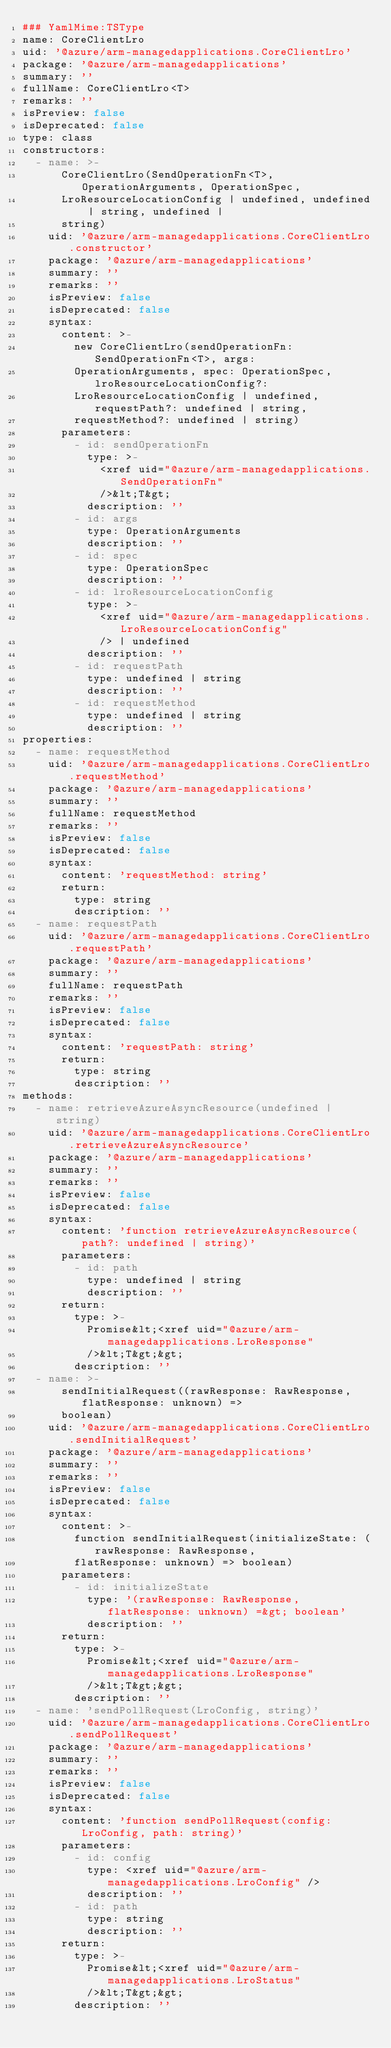<code> <loc_0><loc_0><loc_500><loc_500><_YAML_>### YamlMime:TSType
name: CoreClientLro
uid: '@azure/arm-managedapplications.CoreClientLro'
package: '@azure/arm-managedapplications'
summary: ''
fullName: CoreClientLro<T>
remarks: ''
isPreview: false
isDeprecated: false
type: class
constructors:
  - name: >-
      CoreClientLro(SendOperationFn<T>, OperationArguments, OperationSpec,
      LroResourceLocationConfig | undefined, undefined | string, undefined |
      string)
    uid: '@azure/arm-managedapplications.CoreClientLro.constructor'
    package: '@azure/arm-managedapplications'
    summary: ''
    remarks: ''
    isPreview: false
    isDeprecated: false
    syntax:
      content: >-
        new CoreClientLro(sendOperationFn: SendOperationFn<T>, args:
        OperationArguments, spec: OperationSpec, lroResourceLocationConfig?:
        LroResourceLocationConfig | undefined, requestPath?: undefined | string,
        requestMethod?: undefined | string)
      parameters:
        - id: sendOperationFn
          type: >-
            <xref uid="@azure/arm-managedapplications.SendOperationFn"
            />&lt;T&gt;
          description: ''
        - id: args
          type: OperationArguments
          description: ''
        - id: spec
          type: OperationSpec
          description: ''
        - id: lroResourceLocationConfig
          type: >-
            <xref uid="@azure/arm-managedapplications.LroResourceLocationConfig"
            /> | undefined
          description: ''
        - id: requestPath
          type: undefined | string
          description: ''
        - id: requestMethod
          type: undefined | string
          description: ''
properties:
  - name: requestMethod
    uid: '@azure/arm-managedapplications.CoreClientLro.requestMethod'
    package: '@azure/arm-managedapplications'
    summary: ''
    fullName: requestMethod
    remarks: ''
    isPreview: false
    isDeprecated: false
    syntax:
      content: 'requestMethod: string'
      return:
        type: string
        description: ''
  - name: requestPath
    uid: '@azure/arm-managedapplications.CoreClientLro.requestPath'
    package: '@azure/arm-managedapplications'
    summary: ''
    fullName: requestPath
    remarks: ''
    isPreview: false
    isDeprecated: false
    syntax:
      content: 'requestPath: string'
      return:
        type: string
        description: ''
methods:
  - name: retrieveAzureAsyncResource(undefined | string)
    uid: '@azure/arm-managedapplications.CoreClientLro.retrieveAzureAsyncResource'
    package: '@azure/arm-managedapplications'
    summary: ''
    remarks: ''
    isPreview: false
    isDeprecated: false
    syntax:
      content: 'function retrieveAzureAsyncResource(path?: undefined | string)'
      parameters:
        - id: path
          type: undefined | string
          description: ''
      return:
        type: >-
          Promise&lt;<xref uid="@azure/arm-managedapplications.LroResponse"
          />&lt;T&gt;&gt;
        description: ''
  - name: >-
      sendInitialRequest((rawResponse: RawResponse, flatResponse: unknown) =>
      boolean)
    uid: '@azure/arm-managedapplications.CoreClientLro.sendInitialRequest'
    package: '@azure/arm-managedapplications'
    summary: ''
    remarks: ''
    isPreview: false
    isDeprecated: false
    syntax:
      content: >-
        function sendInitialRequest(initializeState: (rawResponse: RawResponse,
        flatResponse: unknown) => boolean)
      parameters:
        - id: initializeState
          type: '(rawResponse: RawResponse, flatResponse: unknown) =&gt; boolean'
          description: ''
      return:
        type: >-
          Promise&lt;<xref uid="@azure/arm-managedapplications.LroResponse"
          />&lt;T&gt;&gt;
        description: ''
  - name: 'sendPollRequest(LroConfig, string)'
    uid: '@azure/arm-managedapplications.CoreClientLro.sendPollRequest'
    package: '@azure/arm-managedapplications'
    summary: ''
    remarks: ''
    isPreview: false
    isDeprecated: false
    syntax:
      content: 'function sendPollRequest(config: LroConfig, path: string)'
      parameters:
        - id: config
          type: <xref uid="@azure/arm-managedapplications.LroConfig" />
          description: ''
        - id: path
          type: string
          description: ''
      return:
        type: >-
          Promise&lt;<xref uid="@azure/arm-managedapplications.LroStatus"
          />&lt;T&gt;&gt;
        description: ''
</code> 